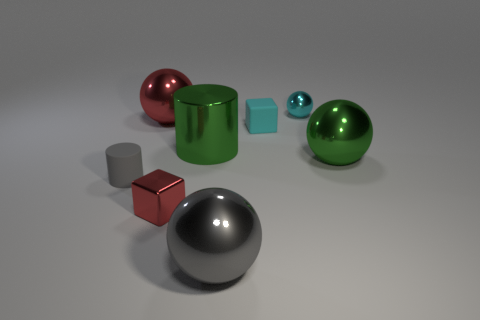There is a big object that is the same color as the small metal cube; what is its shape?
Provide a succinct answer. Sphere. Is the number of large gray things that are on the right side of the gray rubber cylinder less than the number of small gray objects right of the large green sphere?
Offer a very short reply. No. The large thing that is the same shape as the small gray matte thing is what color?
Offer a terse response. Green. Do the ball that is to the left of the gray ball and the tiny red block have the same size?
Offer a very short reply. No. Is the number of small things that are on the right side of the big cylinder less than the number of balls?
Your answer should be very brief. Yes. Are there any other things that are the same size as the red cube?
Provide a succinct answer. Yes. There is a red object that is in front of the matte thing that is behind the large green sphere; how big is it?
Ensure brevity in your answer.  Small. Is there any other thing that is the same shape as the tiny red shiny object?
Make the answer very short. Yes. Are there fewer tiny cyan rubber blocks than red objects?
Your answer should be very brief. Yes. What material is the large thing that is both to the left of the gray shiny thing and on the right side of the big red shiny sphere?
Offer a terse response. Metal. 